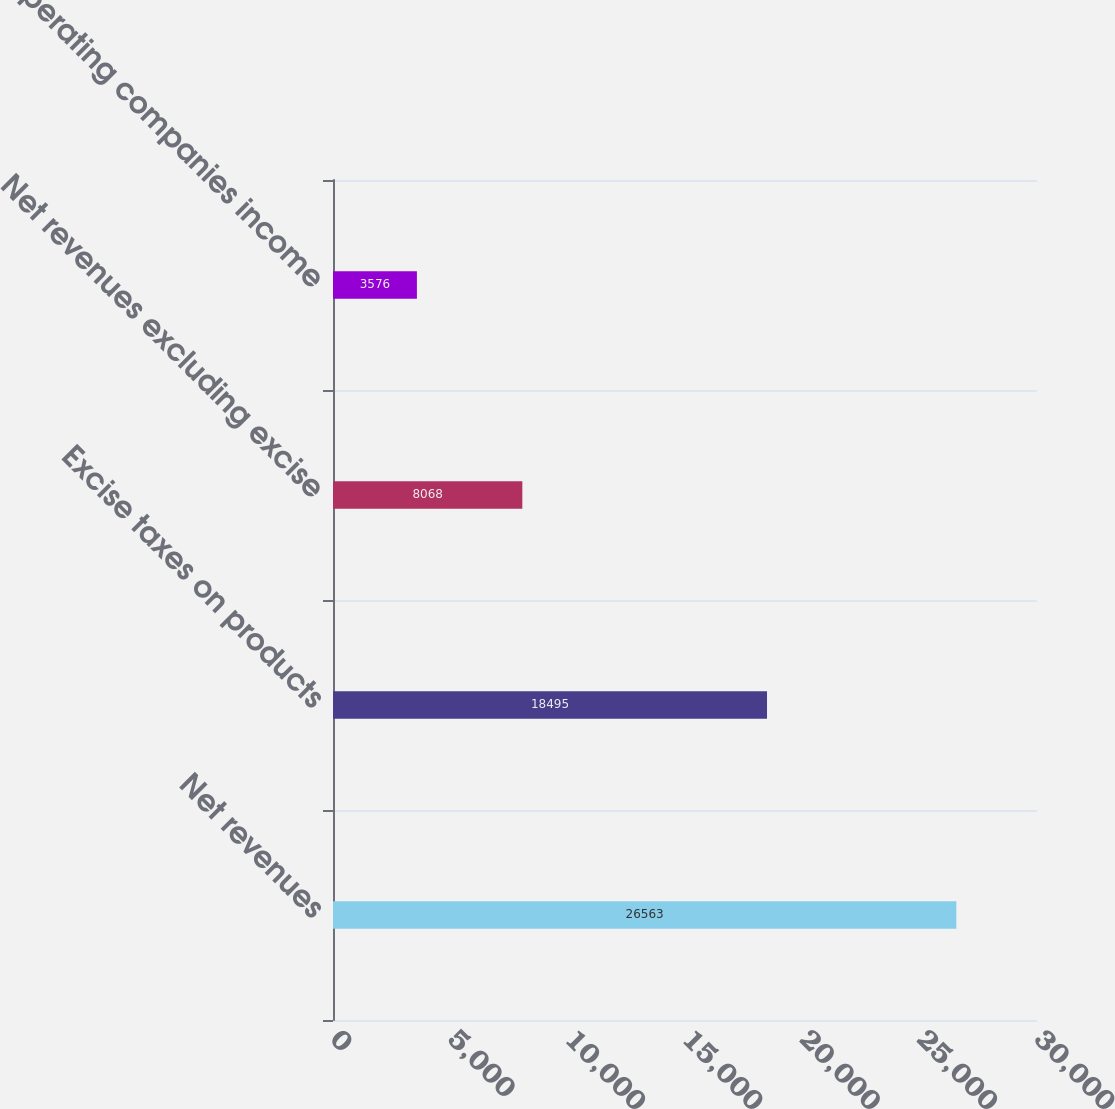Convert chart. <chart><loc_0><loc_0><loc_500><loc_500><bar_chart><fcel>Net revenues<fcel>Excise taxes on products<fcel>Net revenues excluding excise<fcel>Operating companies income<nl><fcel>26563<fcel>18495<fcel>8068<fcel>3576<nl></chart> 